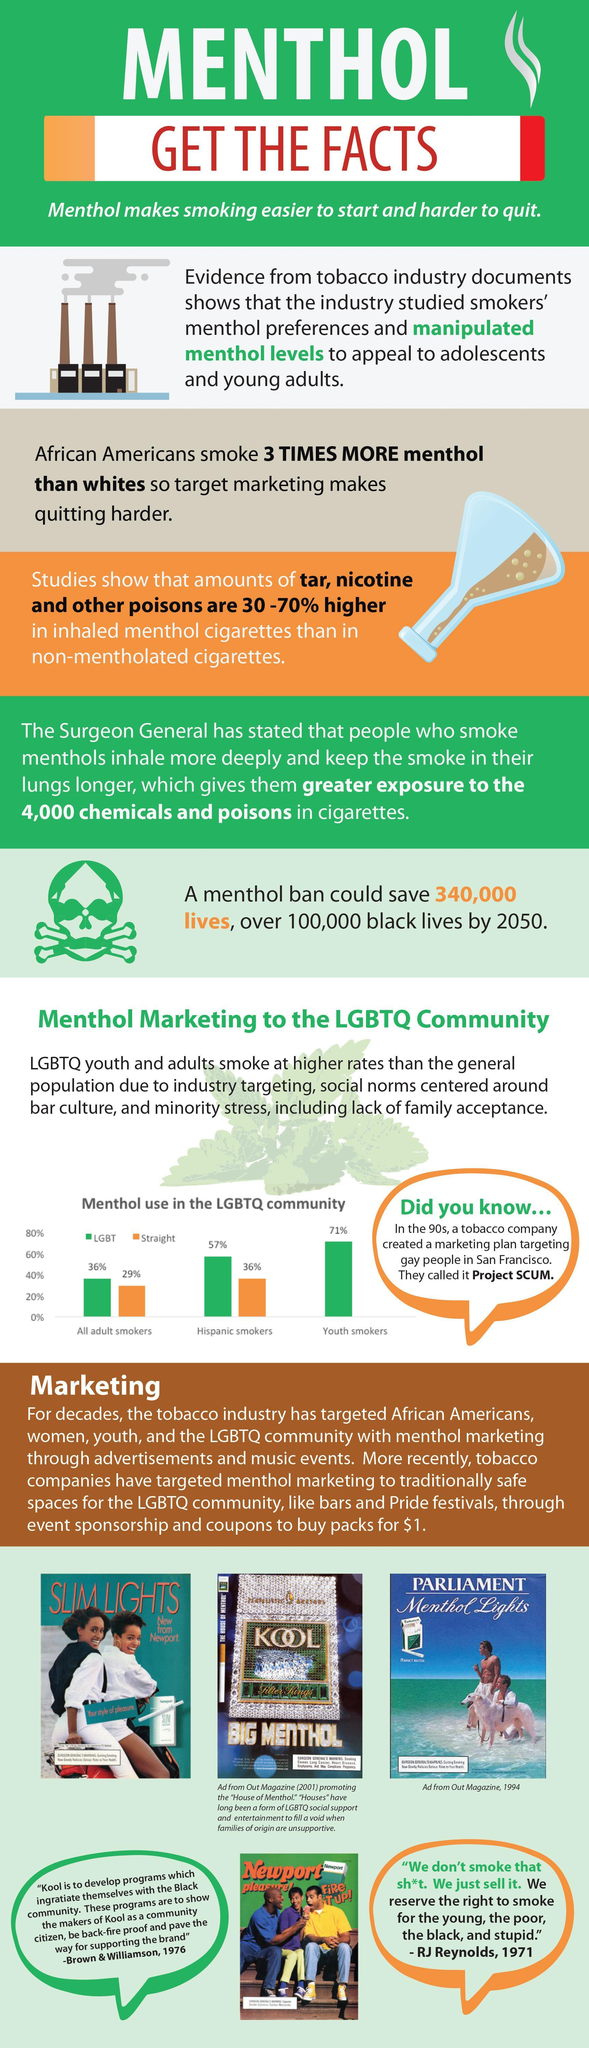Who smoke more menthol cigarettes; whites or african americans?
Answer the question with a short phrase. african americans Among adult smokers who use smoke menthol, what percentage are the LGBT? 36% 